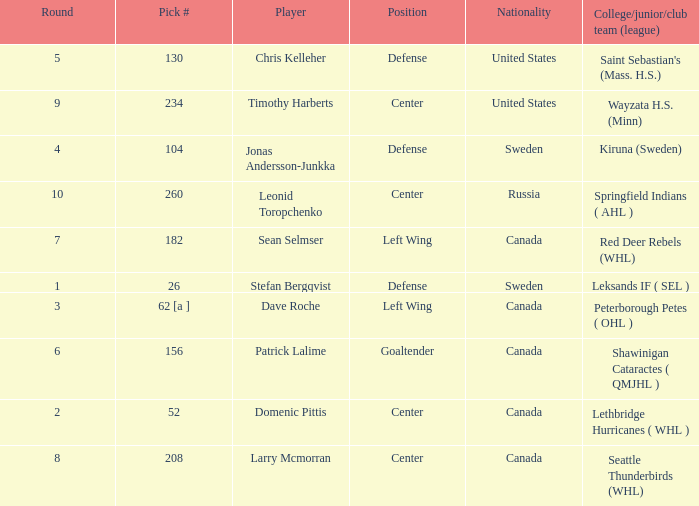What is the nationality of the player whose college/junior/club team (league) is Seattle Thunderbirds (WHL)? Canada. Would you mind parsing the complete table? {'header': ['Round', 'Pick #', 'Player', 'Position', 'Nationality', 'College/junior/club team (league)'], 'rows': [['5', '130', 'Chris Kelleher', 'Defense', 'United States', "Saint Sebastian's (Mass. H.S.)"], ['9', '234', 'Timothy Harberts', 'Center', 'United States', 'Wayzata H.S. (Minn)'], ['4', '104', 'Jonas Andersson-Junkka', 'Defense', 'Sweden', 'Kiruna (Sweden)'], ['10', '260', 'Leonid Toropchenko', 'Center', 'Russia', 'Springfield Indians ( AHL )'], ['7', '182', 'Sean Selmser', 'Left Wing', 'Canada', 'Red Deer Rebels (WHL)'], ['1', '26', 'Stefan Bergqvist', 'Defense', 'Sweden', 'Leksands IF ( SEL )'], ['3', '62 [a ]', 'Dave Roche', 'Left Wing', 'Canada', 'Peterborough Petes ( OHL )'], ['6', '156', 'Patrick Lalime', 'Goaltender', 'Canada', 'Shawinigan Cataractes ( QMJHL )'], ['2', '52', 'Domenic Pittis', 'Center', 'Canada', 'Lethbridge Hurricanes ( WHL )'], ['8', '208', 'Larry Mcmorran', 'Center', 'Canada', 'Seattle Thunderbirds (WHL)']]} 